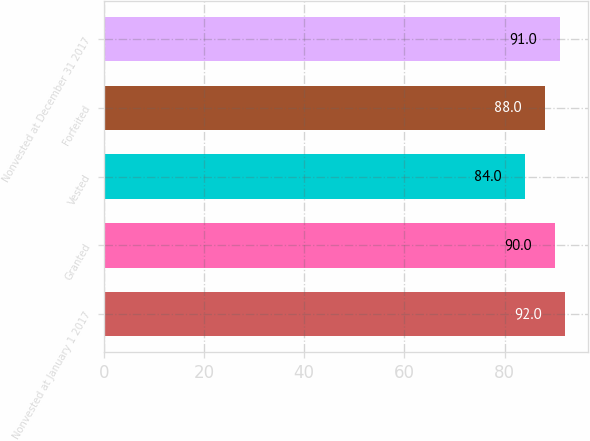Convert chart. <chart><loc_0><loc_0><loc_500><loc_500><bar_chart><fcel>Nonvested at January 1 2017<fcel>Granted<fcel>Vested<fcel>Forfeited<fcel>Nonvested at December 31 2017<nl><fcel>92<fcel>90<fcel>84<fcel>88<fcel>91<nl></chart> 